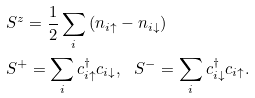Convert formula to latex. <formula><loc_0><loc_0><loc_500><loc_500>& S ^ { z } = \frac { 1 } { 2 } \sum _ { i } \left ( n _ { i \uparrow } - n _ { i \downarrow } \right ) \\ & S ^ { + } = \sum _ { i } c _ { i \uparrow } ^ { \dag } c _ { i \downarrow } , \ \ S ^ { - } = \sum _ { i } c _ { i \downarrow } ^ { \dag } c _ { i \uparrow } .</formula> 